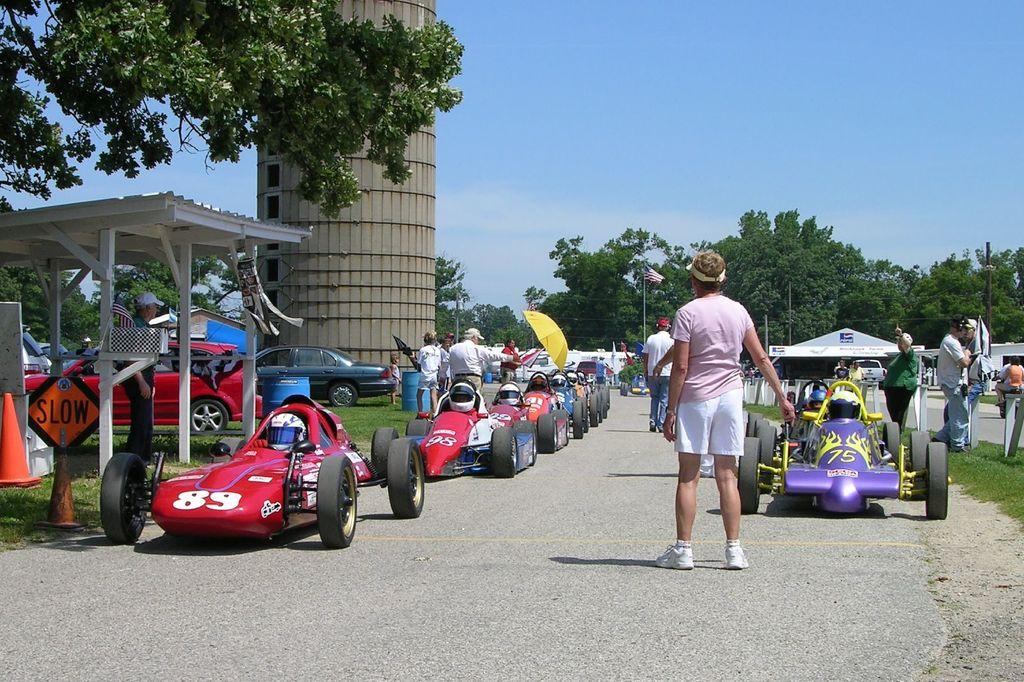What can be seen on the road in the image? There are cars on the road in the image. What are the people near the cars doing? The people standing near the cars are visible in the image. What type of vegetation can be seen in the image? There are trees visible in the image. What is the condition of the sky in the image? The sky is clear in the image. What type of cork can be seen floating in the image? There is no cork present in the image; it features cars on the road, people, trees, and a clear sky. What kind of bubble is visible in the image? There is no bubble present in the image. 